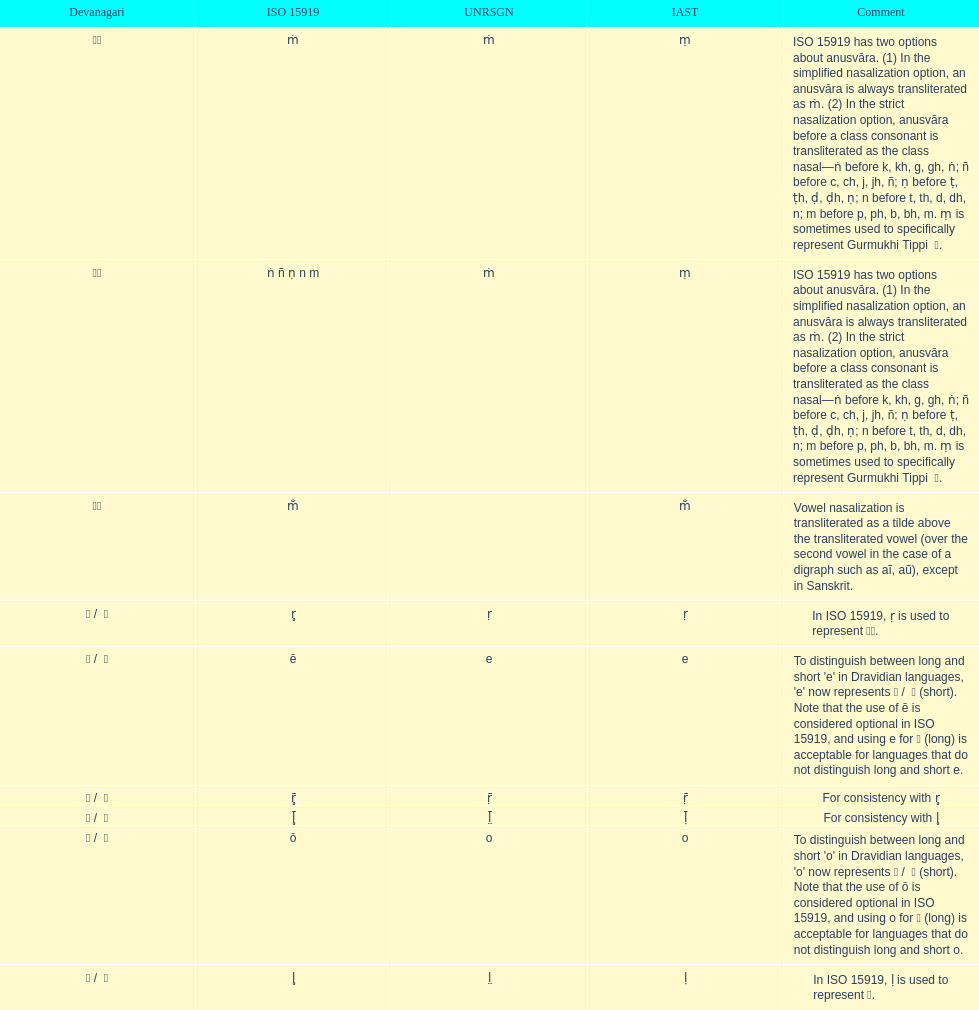What is the total number of translations? 8. 